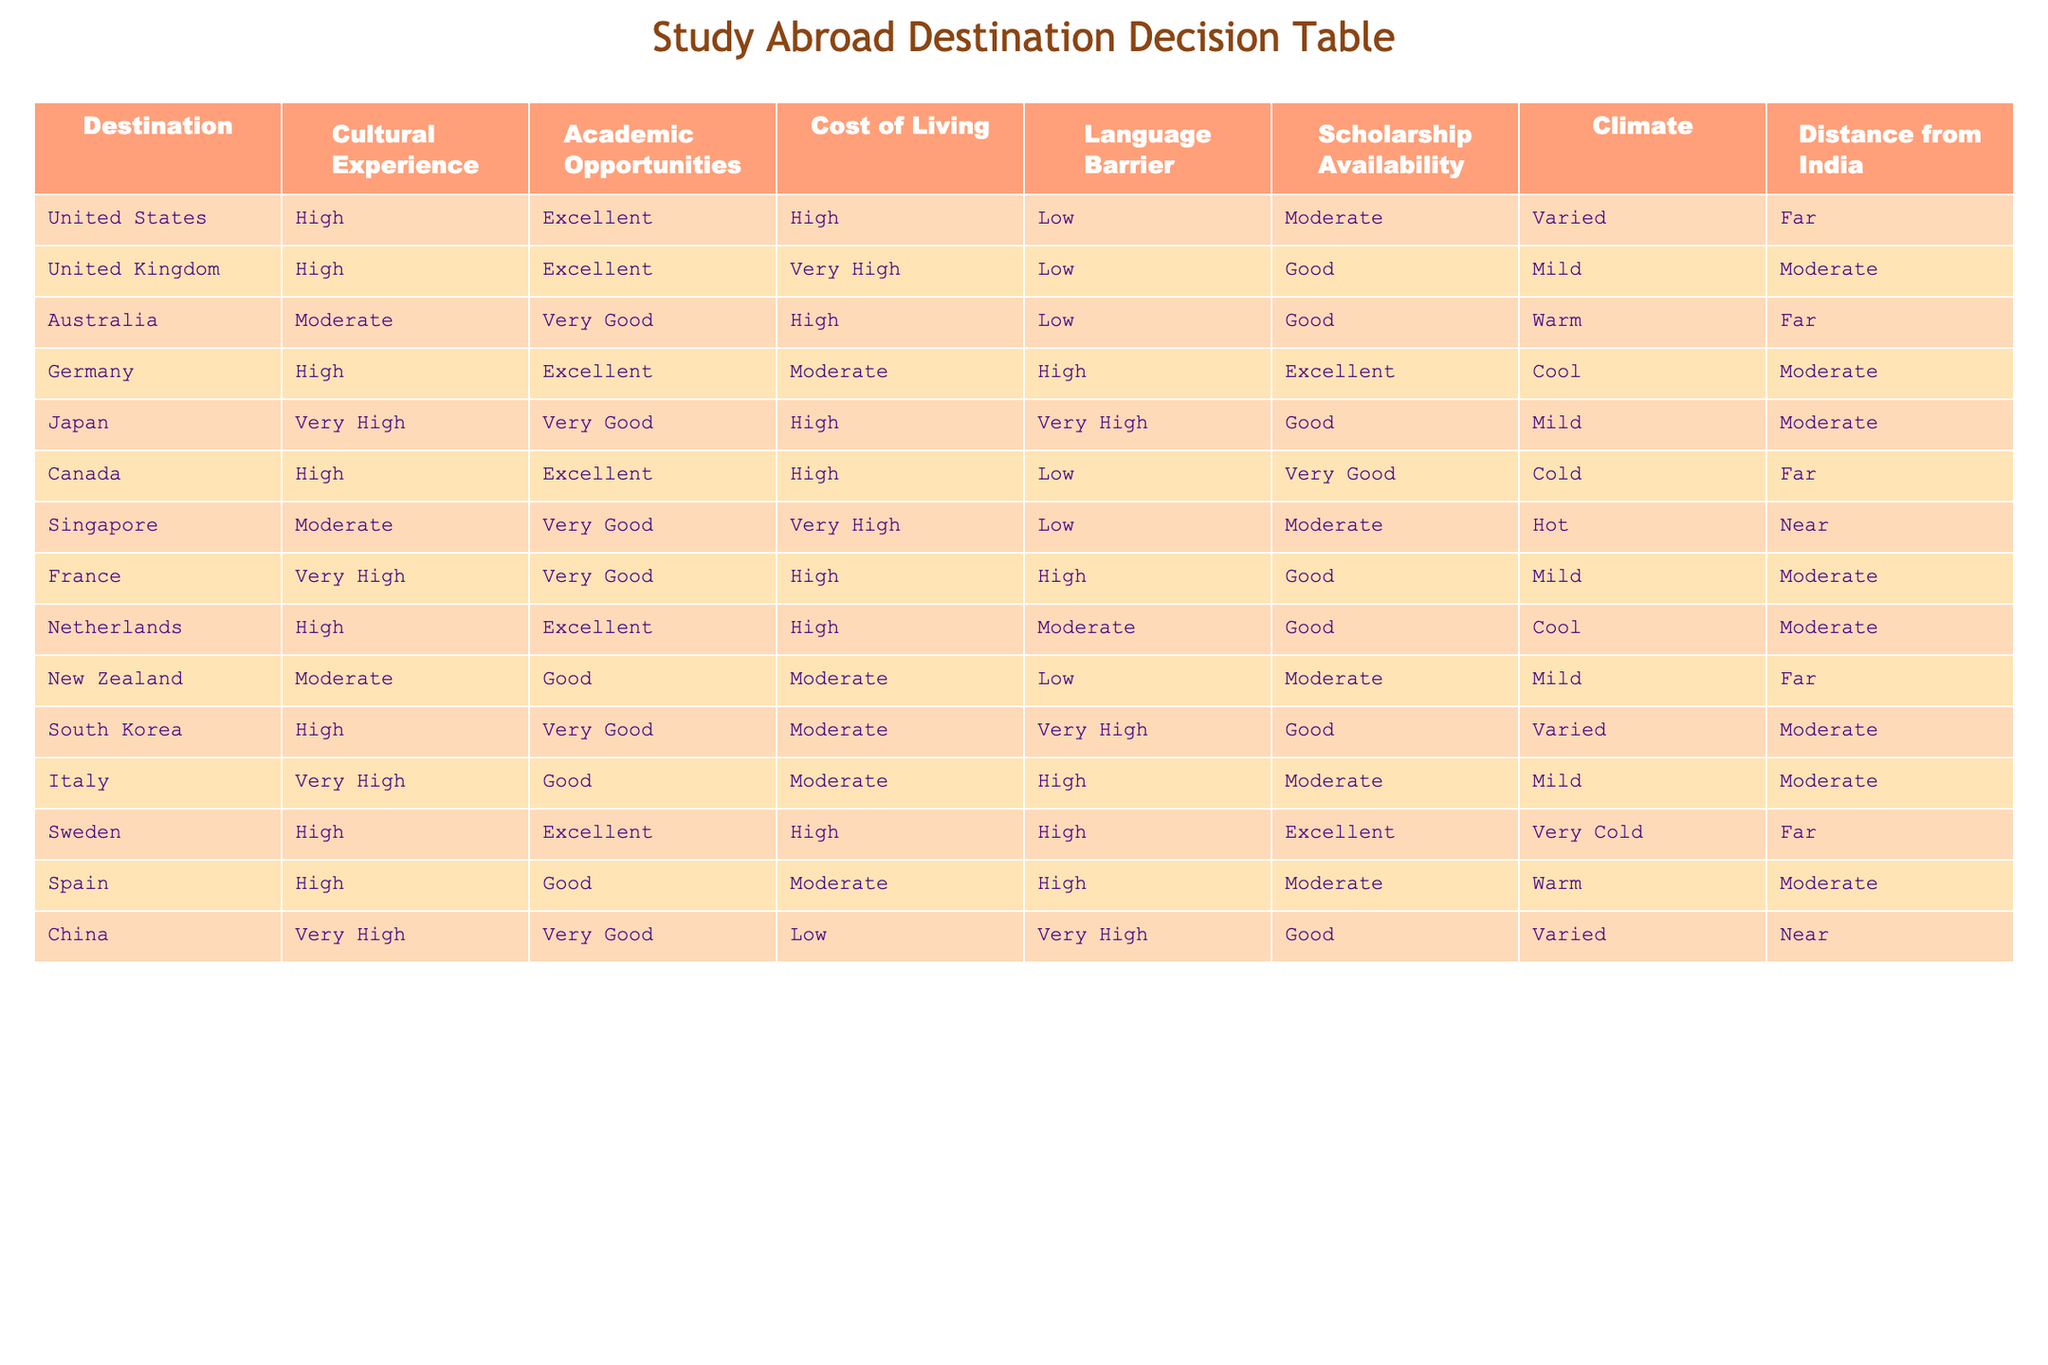What is the cost of living in Germany? Referring to the table, Germany's cost of living is listed as Moderate.
Answer: Moderate Which destination has the highest academic opportunities? The table indicates that both the United States and the United Kingdom have Excellent academic opportunities, making them the highest.
Answer: United States and United Kingdom Is there a language barrier in Canada? According to the table, Canada is marked with a Low language barrier.
Answer: No What is the average distance from India for all destinations listed? To find the average distance, count the entries (12), identify distances by the categories (Far=4, Moderate=5, Near=3). Replace categories with numerical values (Far=4, Moderate=2, Near=1), keeping in mind that 'Far' appears 7 times, 'Moderate' 4 times, and 'Near' 1 time. Then, calculating: (7*4 + 4*2 + 1*1) / 12 = 3.08, but to keep it as in categories, it would roughly equal between Far and Moderate.
Answer: Moderately Far Which destination has the combination of Very High cultural experience and Very Good academic opportunities? By examining the table, Japan is the only destination with Very High cultural experience and Very Good academic opportunities.
Answer: Japan Does Spain provide Good scholarship availability? In the table, Spain is listed with Moderate scholarship availability. Thus, it does not provide Good availability.
Answer: No Which destination is closest to India with a Moderate scholarship availability? Looking at the table, both Singapore and China have Moderate scholarship availability, and they are the closest (Near).
Answer: Singapore and China Which country has a High cost of living and Excellent academic opportunities? The table shows that Canada matches both criteria of High cost of living and Excellent academic opportunities.
Answer: Canada Are there any destinations with a Very High cultural experience that also have a Low cost of living? From the table, it can be seen that there are no destinations with a Very High cultural experience that also have a Low cost of living.
Answer: No 